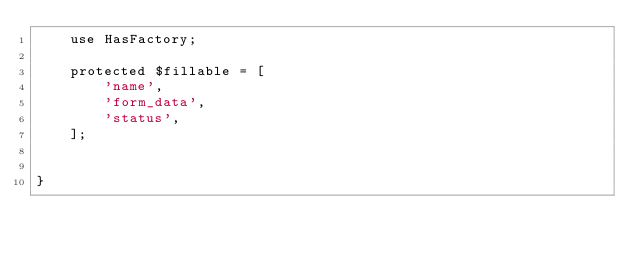Convert code to text. <code><loc_0><loc_0><loc_500><loc_500><_PHP_>    use HasFactory;

    protected $fillable = [
        'name',
        'form_data',
        'status',
    ];


}
</code> 